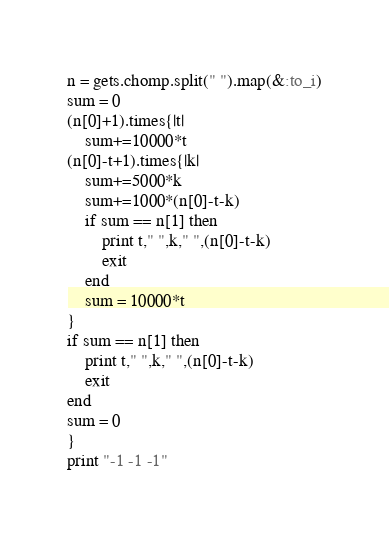Convert code to text. <code><loc_0><loc_0><loc_500><loc_500><_Ruby_>n = gets.chomp.split(" ").map(&:to_i)
sum = 0
(n[0]+1).times{|t|
    sum+=10000*t
(n[0]-t+1).times{|k|
    sum+=5000*k
    sum+=1000*(n[0]-t-k)
    if sum == n[1] then
        print t," ",k," ",(n[0]-t-k)
        exit
    end
    sum = 10000*t
}
if sum == n[1] then
    print t," ",k," ",(n[0]-t-k)
    exit
end
sum = 0
}
print "-1 -1 -1"</code> 